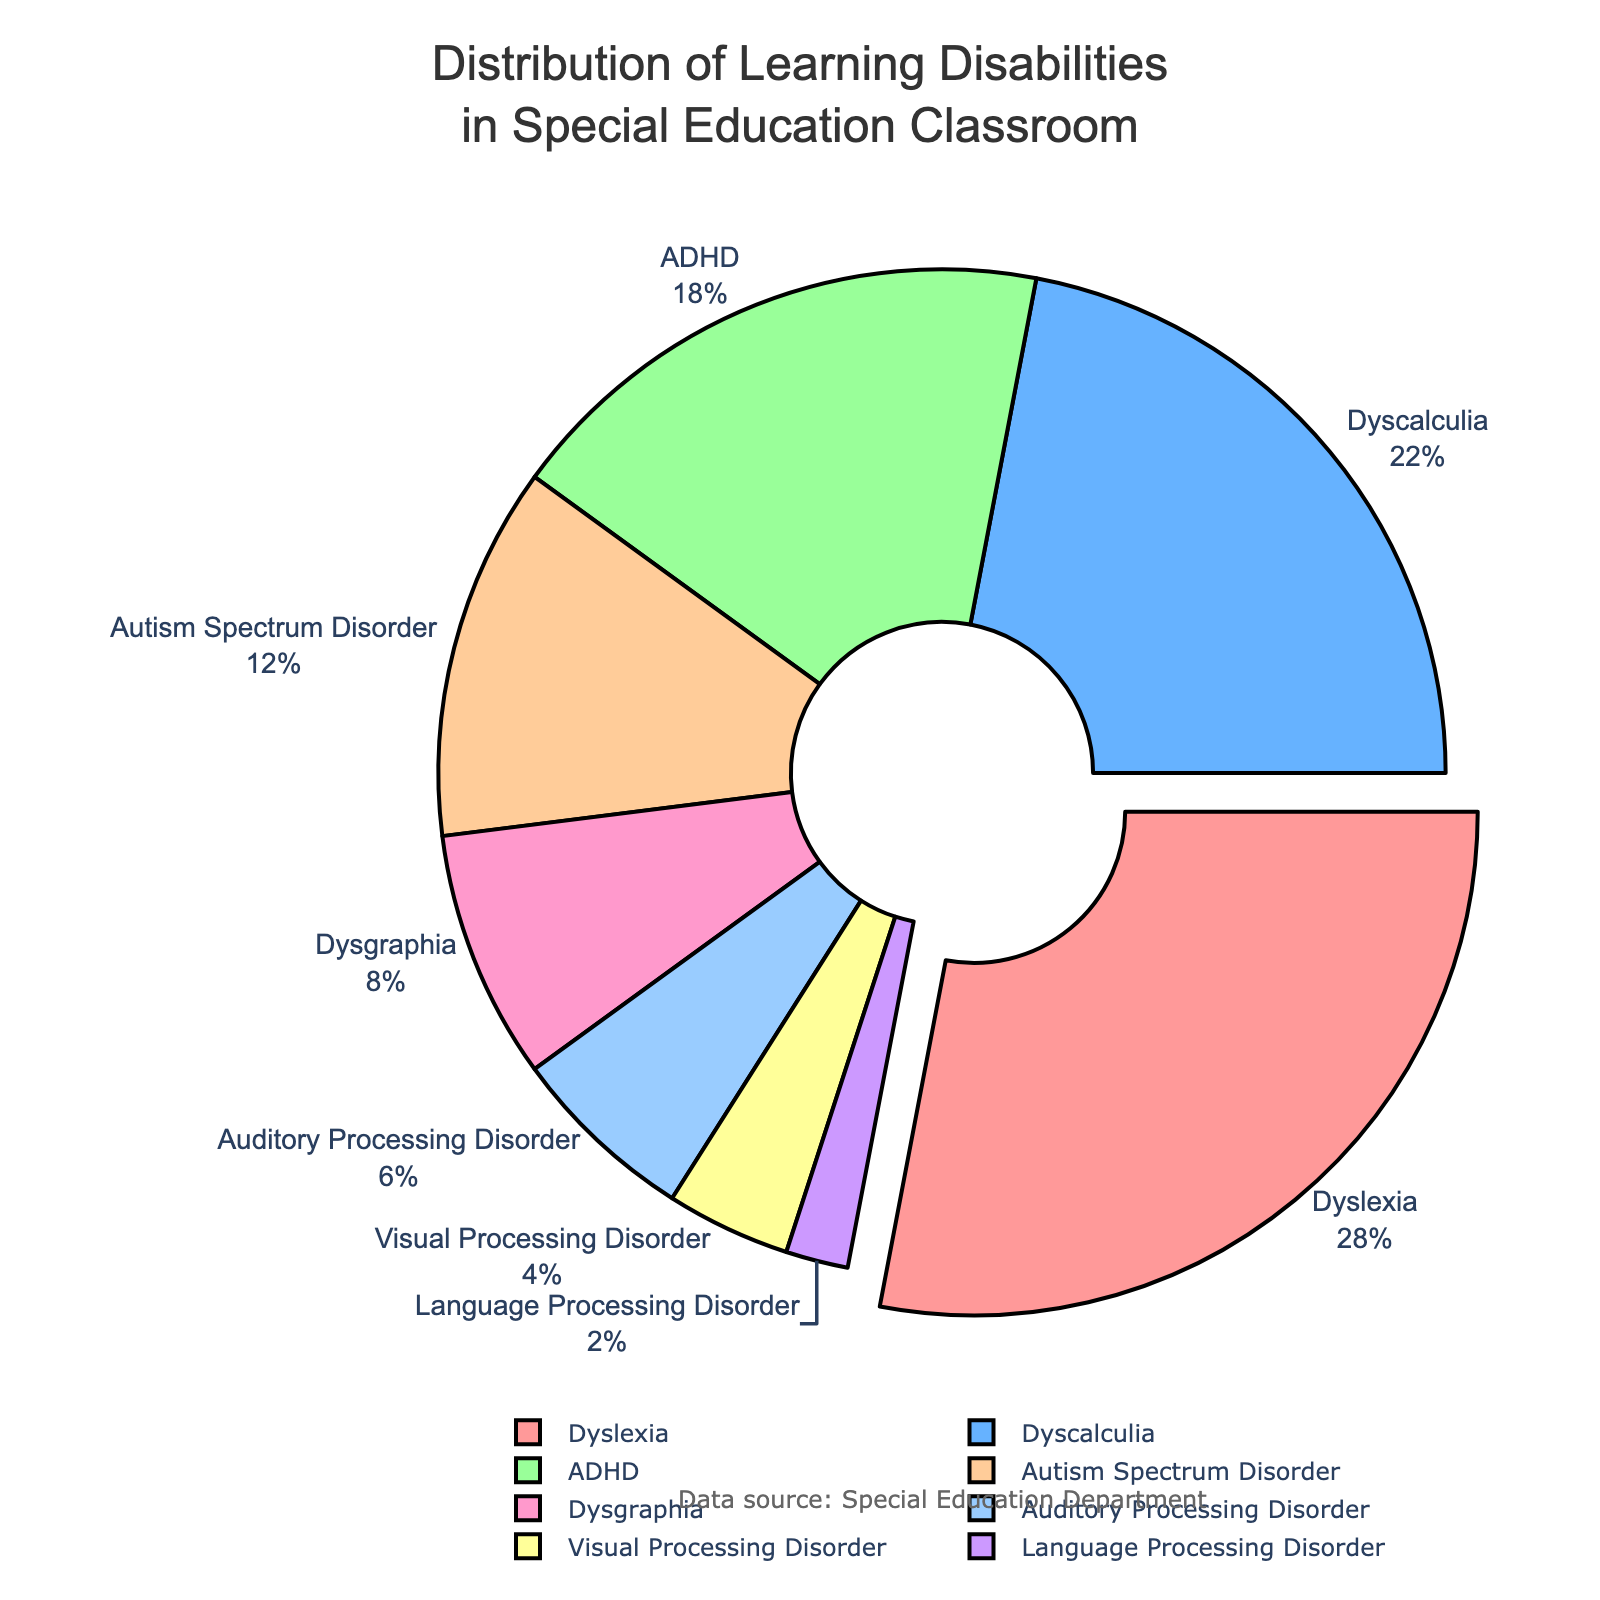Which learning disability has the highest percentage? The largest segment in a pie chart represents the highest percentage. The label for this segment reads "Dyslexia" with 28%.
Answer: Dyslexia What is the total percentage for Dysgraphia, Auditory Processing Disorder, and Language Processing Disorder combined? Add the percentages for Dysgraphia (8%), Auditory Processing Disorder (6%), and Language Processing Disorder (2%) together: 8 + 6 + 2 = 16%.
Answer: 16% Is the percentage of ADHD greater than Dysgraphia and Visual Processing Disorder combined? Compare the percentage of ADHD (18%) to the combined percentage of Dysgraphia (8%) and Visual Processing Disorder (4%): 8 + 4 = 12%. Since 18% is greater than 12%, ADHD has a higher percentage.
Answer: Yes Which segment is visually pulled out from the pie chart? The segment that is pulled out indicates it has the highest percentage. This segment is labeled "Dyslexia".
Answer: Dyslexia How much more prevalent is Dyslexia compared to Visual Processing Disorder? Subtract the percentage of Visual Processing Disorder (4%) from Dyslexia (28%): 28 - 4 = 24%.
Answer: 24% Is the percentage of Autism Spectrum Disorder less than Dyscalculia and Auditory Processing Disorder combined? Compare the percentage of Autism Spectrum Disorder (12%) to the combined percentage of Dyscalculia (22%) and Auditory Processing Disorder (6%): 22 + 6 = 28%. Since 12% is less than 28%, Autism Spectrum Disorder has a lower percentage.
Answer: Yes Rank the learning disabilities from most to least prevalent. Order the percentages from highest to lowest: Dyslexia (28%), Dyscalculia (22%), ADHD (18%), Autism Spectrum Disorder (12%), Dysgraphia (8%), Auditory Processing Disorder (6%), Visual Processing Disorder (4%), Language Processing Disorder (2%).
Answer: Dyslexia, Dyscalculia, ADHD, Autism Spectrum Disorder, Dysgraphia, Auditory Processing Disorder, Visual Processing Disorder, Language Processing Disorder Which three learning disabilities have the smallest percentages, and what is their total percentage? Identify the three smallest percentages: Language Processing Disorder (2%), Visual Processing Disorder (4%), and Auditory Processing Disorder (6%), and then add them together: 2 + 4 + 6 = 12%.
Answer: Language Processing Disorder, Visual Processing Disorder, Auditory Processing Disorder; 12% Are there any learning disabilities with equal percentages, and if so, which ones? Compare the percentages of each disability and check for equality. No segments in the pie chart have equal percentages.
Answer: No What is the difference in percentage between Dyscalculia and Autism Spectrum Disorder? Subtract the percentage of Autism Spectrum Disorder (12%) from Dyscalculia (22%): 22 - 12 = 10%.
Answer: 10% 